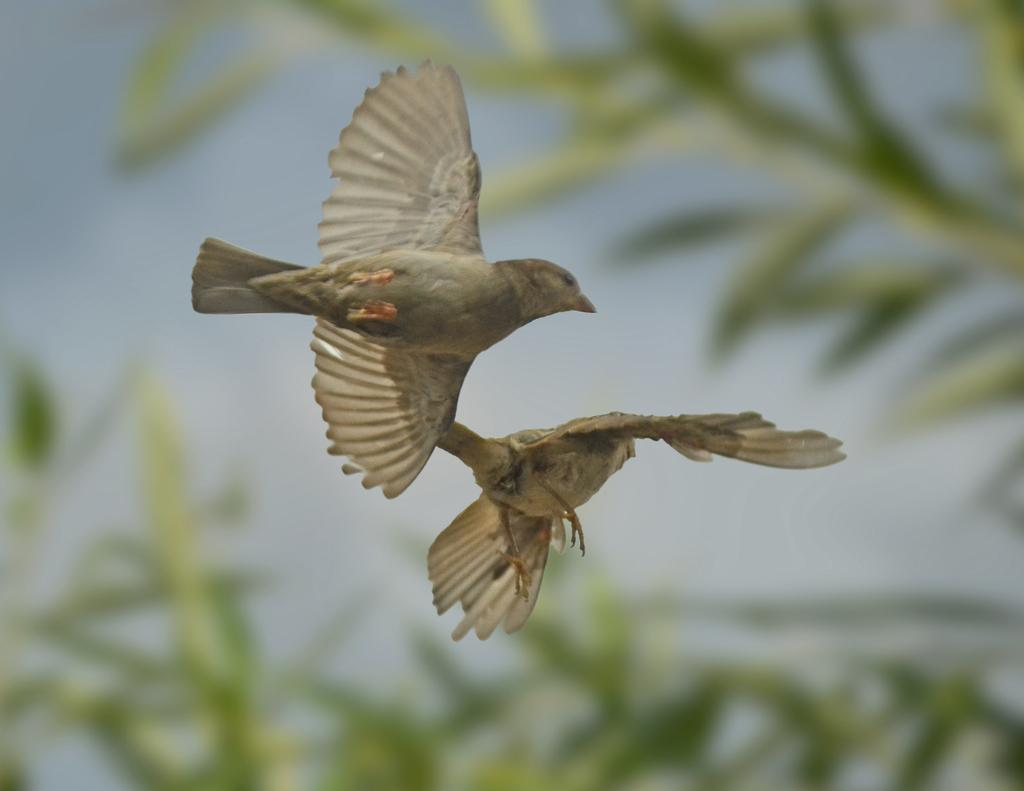What is happening in the image involving birds? There are two birds flying in the air. What can be seen in the background of the image? Leaves are visible in the background. How would you describe the background of the image? The background of the image is blurred. What type of plastic is being used by the maid in the image? There is no maid or plastic present in the image. What year is depicted in the image? The image does not depict a specific year. 